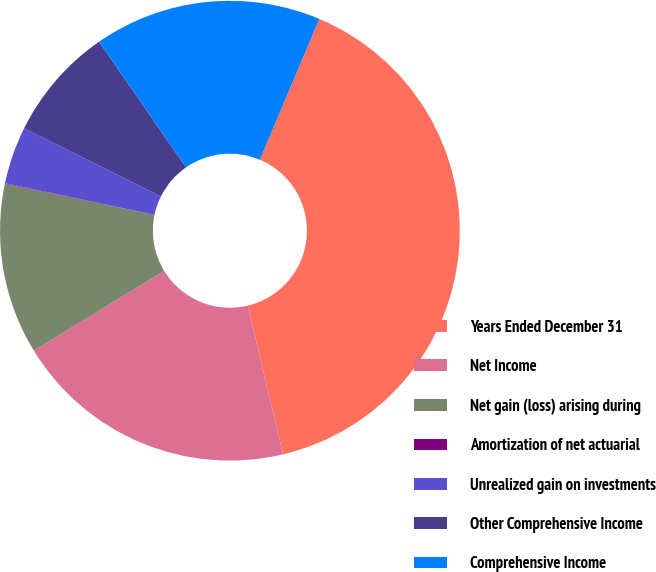Convert chart. <chart><loc_0><loc_0><loc_500><loc_500><pie_chart><fcel>Years Ended December 31<fcel>Net Income<fcel>Net gain (loss) arising during<fcel>Amortization of net actuarial<fcel>Unrealized gain on investments<fcel>Other Comprehensive Income<fcel>Comprehensive Income<nl><fcel>39.93%<fcel>19.98%<fcel>12.01%<fcel>0.04%<fcel>4.03%<fcel>8.02%<fcel>16.0%<nl></chart> 